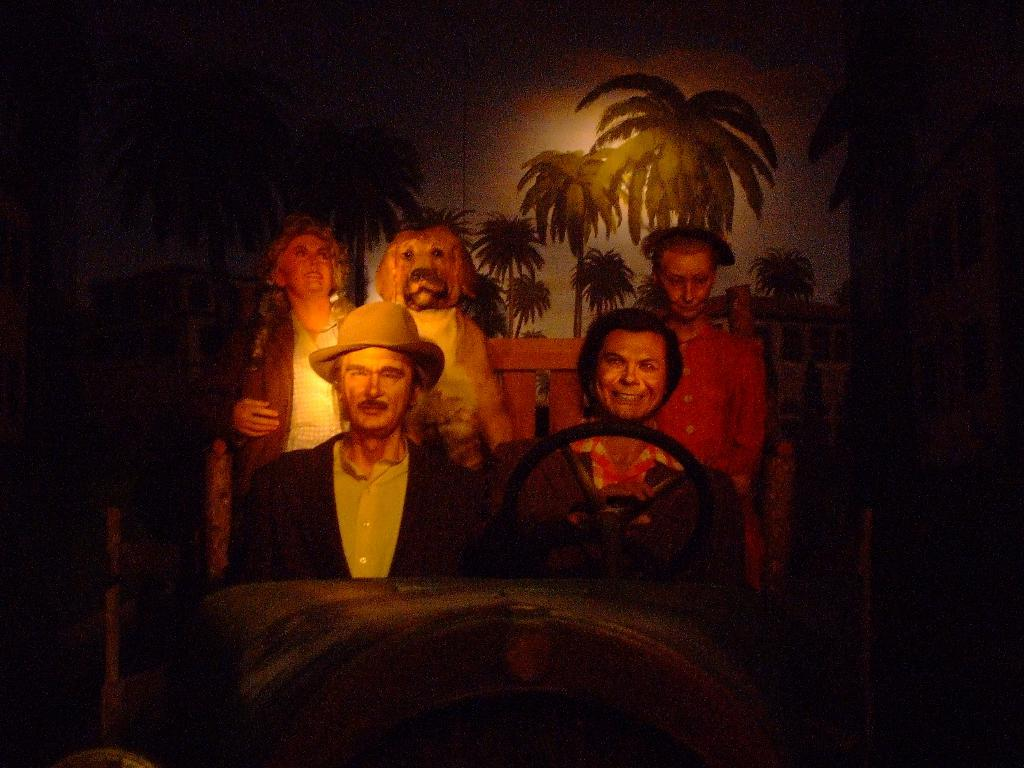What type of natural elements can be seen in the image? There are trees in the image. Are there any living beings present in the image? Yes, there are people and it appears that there is a dog in the image. What type of artwork is the image? The image is a painting. How many babies are swimming with the jellyfish in the image? There are no babies or jellyfish present in the image; it features trees, people, and a dog in a painting. 